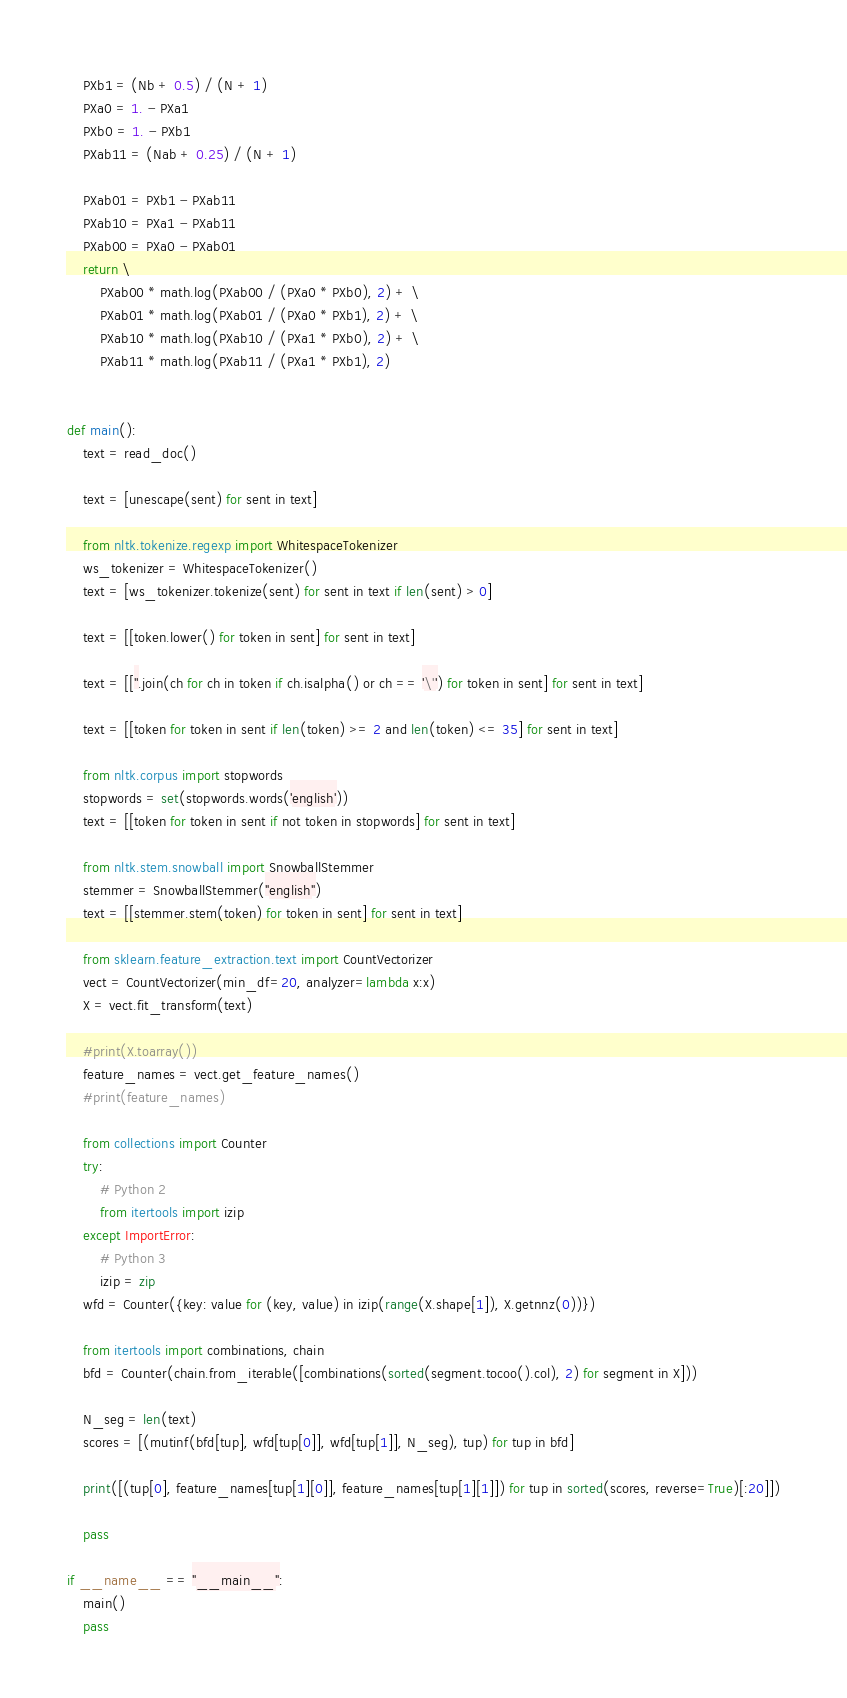Convert code to text. <code><loc_0><loc_0><loc_500><loc_500><_Python_>    PXb1 = (Nb + 0.5) / (N + 1)
    PXa0 = 1. - PXa1
    PXb0 = 1. - PXb1
    PXab11 = (Nab + 0.25) / (N + 1)

    PXab01 = PXb1 - PXab11
    PXab10 = PXa1 - PXab11
    PXab00 = PXa0 - PXab01
    return \
        PXab00 * math.log(PXab00 / (PXa0 * PXb0), 2) + \
        PXab01 * math.log(PXab01 / (PXa0 * PXb1), 2) + \
        PXab10 * math.log(PXab10 / (PXa1 * PXb0), 2) + \
        PXab11 * math.log(PXab11 / (PXa1 * PXb1), 2)


def main():
    text = read_doc()

    text = [unescape(sent) for sent in text]

    from nltk.tokenize.regexp import WhitespaceTokenizer
    ws_tokenizer = WhitespaceTokenizer()
    text = [ws_tokenizer.tokenize(sent) for sent in text if len(sent) > 0]

    text = [[token.lower() for token in sent] for sent in text]

    text = [[''.join(ch for ch in token if ch.isalpha() or ch == '\'') for token in sent] for sent in text]

    text = [[token for token in sent if len(token) >= 2 and len(token) <= 35] for sent in text]

    from nltk.corpus import stopwords
    stopwords = set(stopwords.words('english'))
    text = [[token for token in sent if not token in stopwords] for sent in text]

    from nltk.stem.snowball import SnowballStemmer
    stemmer = SnowballStemmer("english")
    text = [[stemmer.stem(token) for token in sent] for sent in text]

    from sklearn.feature_extraction.text import CountVectorizer
    vect = CountVectorizer(min_df=20, analyzer=lambda x:x)
    X = vect.fit_transform(text)

    #print(X.toarray())
    feature_names = vect.get_feature_names()
    #print(feature_names)

    from collections import Counter
    try:
        # Python 2
        from itertools import izip
    except ImportError:
        # Python 3
        izip = zip
    wfd = Counter({key: value for (key, value) in izip(range(X.shape[1]), X.getnnz(0))})

    from itertools import combinations, chain
    bfd = Counter(chain.from_iterable([combinations(sorted(segment.tocoo().col), 2) for segment in X]))

    N_seg = len(text)
    scores = [(mutinf(bfd[tup], wfd[tup[0]], wfd[tup[1]], N_seg), tup) for tup in bfd]

    print([(tup[0], feature_names[tup[1][0]], feature_names[tup[1][1]]) for tup in sorted(scores, reverse=True)[:20]])

    pass

if __name__ == "__main__":
    main()
    pass
</code> 